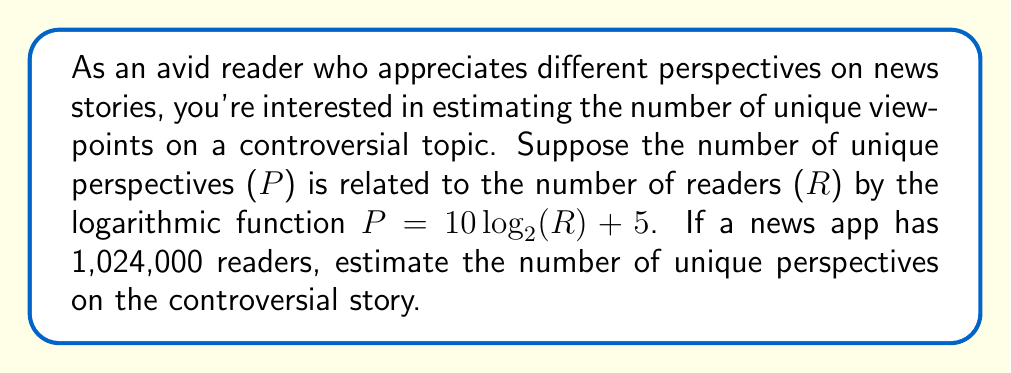Show me your answer to this math problem. Let's approach this step-by-step:

1) We're given the function $P = 10 \log_{2}(R) + 5$, where:
   P = number of unique perspectives
   R = number of readers

2) We're told that R = 1,024,000

3) Let's substitute this into our equation:
   $P = 10 \log_{2}(1,024,000) + 5$

4) To simplify $\log_{2}(1,024,000)$, recall that $1,024,000 = 1024 * 1000 = 2^{10} * 10^3$

5) Using the logarithm property $\log_a(x^n) = n\log_a(x)$, we can simplify:
   $\log_{2}(1,024,000) = \log_{2}(2^{10} * 10^3) = \log_{2}(2^{10}) + \log_{2}(10^3)$

6) $\log_{2}(2^{10}) = 10$, so our equation becomes:
   $P = 10(10 + \log_{2}(10^3)) + 5$

7) $\log_{2}(10^3) \approx 9.97$ (using a calculator or log tables)

8) Substituting this in:
   $P = 10(10 + 9.97) + 5 = 10(19.97) + 5 = 199.7 + 5 = 204.7$

9) Since we're estimating and P represents a count of perspectives, we'll round to the nearest whole number.
Answer: 205 unique perspectives 